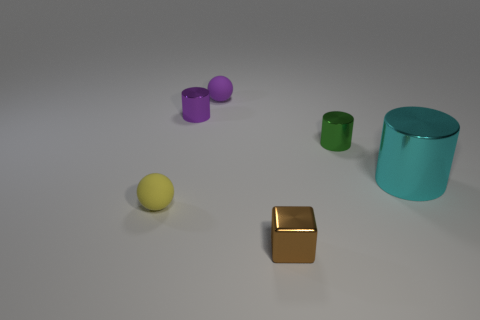Add 1 small green cylinders. How many objects exist? 7 Subtract all cubes. How many objects are left? 5 Subtract all red metal cylinders. Subtract all brown shiny things. How many objects are left? 5 Add 4 big cyan metal objects. How many big cyan metal objects are left? 5 Add 1 small yellow spheres. How many small yellow spheres exist? 2 Subtract 0 green blocks. How many objects are left? 6 